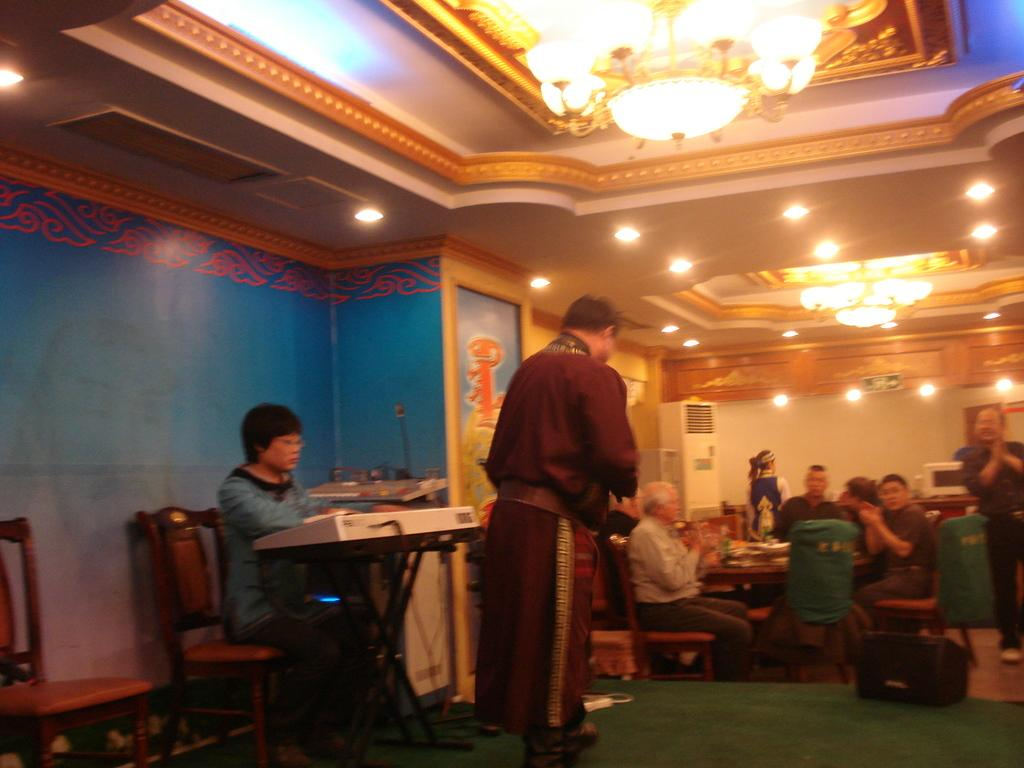What is present in the image that serves as a barrier or divider? There is a wall in the image. What are the people in the image doing? The people in the image are sitting on chairs. What piece of furniture can be seen in the image that is typically used for placing objects or serving food? There is a table in the image. What type of bead is being used to make a decision in the image? There is no bead present in the image, nor is there any indication of a decision-making process. 